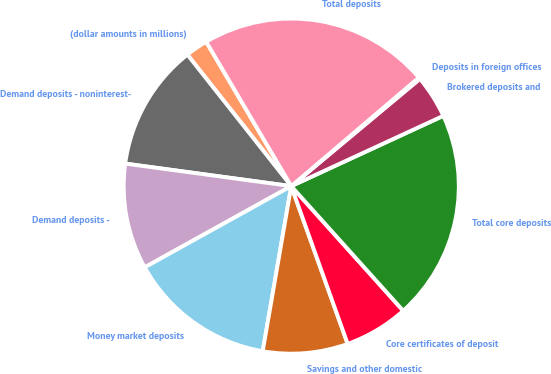Convert chart. <chart><loc_0><loc_0><loc_500><loc_500><pie_chart><fcel>(dollar amounts in millions)<fcel>Demand deposits - noninterest-<fcel>Demand deposits -<fcel>Money market deposits<fcel>Savings and other domestic<fcel>Core certificates of deposit<fcel>Total core deposits<fcel>Brokered deposits and<fcel>Deposits in foreign offices<fcel>Total deposits<nl><fcel>2.17%<fcel>12.21%<fcel>10.2%<fcel>14.22%<fcel>8.19%<fcel>6.18%<fcel>20.24%<fcel>4.17%<fcel>0.16%<fcel>22.25%<nl></chart> 